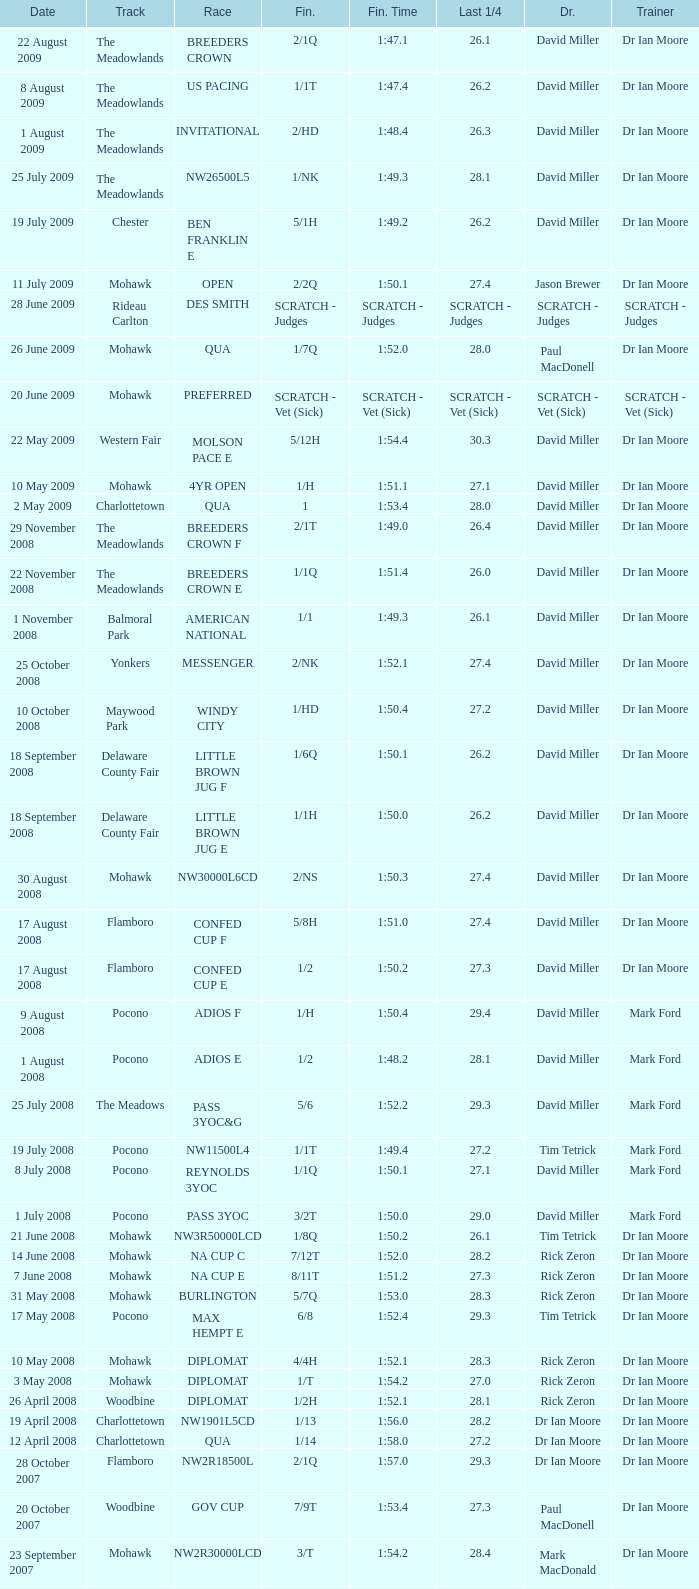What is the last 1/4 for the QUA race with a finishing time of 2:03.1? 29.2. Could you parse the entire table? {'header': ['Date', 'Track', 'Race', 'Fin.', 'Fin. Time', 'Last 1/4', 'Dr.', 'Trainer'], 'rows': [['22 August 2009', 'The Meadowlands', 'BREEDERS CROWN', '2/1Q', '1:47.1', '26.1', 'David Miller', 'Dr Ian Moore'], ['8 August 2009', 'The Meadowlands', 'US PACING', '1/1T', '1:47.4', '26.2', 'David Miller', 'Dr Ian Moore'], ['1 August 2009', 'The Meadowlands', 'INVITATIONAL', '2/HD', '1:48.4', '26.3', 'David Miller', 'Dr Ian Moore'], ['25 July 2009', 'The Meadowlands', 'NW26500L5', '1/NK', '1:49.3', '28.1', 'David Miller', 'Dr Ian Moore'], ['19 July 2009', 'Chester', 'BEN FRANKLIN E', '5/1H', '1:49.2', '26.2', 'David Miller', 'Dr Ian Moore'], ['11 July 2009', 'Mohawk', 'OPEN', '2/2Q', '1:50.1', '27.4', 'Jason Brewer', 'Dr Ian Moore'], ['28 June 2009', 'Rideau Carlton', 'DES SMITH', 'SCRATCH - Judges', 'SCRATCH - Judges', 'SCRATCH - Judges', 'SCRATCH - Judges', 'SCRATCH - Judges'], ['26 June 2009', 'Mohawk', 'QUA', '1/7Q', '1:52.0', '28.0', 'Paul MacDonell', 'Dr Ian Moore'], ['20 June 2009', 'Mohawk', 'PREFERRED', 'SCRATCH - Vet (Sick)', 'SCRATCH - Vet (Sick)', 'SCRATCH - Vet (Sick)', 'SCRATCH - Vet (Sick)', 'SCRATCH - Vet (Sick)'], ['22 May 2009', 'Western Fair', 'MOLSON PACE E', '5/12H', '1:54.4', '30.3', 'David Miller', 'Dr Ian Moore'], ['10 May 2009', 'Mohawk', '4YR OPEN', '1/H', '1:51.1', '27.1', 'David Miller', 'Dr Ian Moore'], ['2 May 2009', 'Charlottetown', 'QUA', '1', '1:53.4', '28.0', 'David Miller', 'Dr Ian Moore'], ['29 November 2008', 'The Meadowlands', 'BREEDERS CROWN F', '2/1T', '1:49.0', '26.4', 'David Miller', 'Dr Ian Moore'], ['22 November 2008', 'The Meadowlands', 'BREEDERS CROWN E', '1/1Q', '1:51.4', '26.0', 'David Miller', 'Dr Ian Moore'], ['1 November 2008', 'Balmoral Park', 'AMERICAN NATIONAL', '1/1', '1:49.3', '26.1', 'David Miller', 'Dr Ian Moore'], ['25 October 2008', 'Yonkers', 'MESSENGER', '2/NK', '1:52.1', '27.4', 'David Miller', 'Dr Ian Moore'], ['10 October 2008', 'Maywood Park', 'WINDY CITY', '1/HD', '1:50.4', '27.2', 'David Miller', 'Dr Ian Moore'], ['18 September 2008', 'Delaware County Fair', 'LITTLE BROWN JUG F', '1/6Q', '1:50.1', '26.2', 'David Miller', 'Dr Ian Moore'], ['18 September 2008', 'Delaware County Fair', 'LITTLE BROWN JUG E', '1/1H', '1:50.0', '26.2', 'David Miller', 'Dr Ian Moore'], ['30 August 2008', 'Mohawk', 'NW30000L6CD', '2/NS', '1:50.3', '27.4', 'David Miller', 'Dr Ian Moore'], ['17 August 2008', 'Flamboro', 'CONFED CUP F', '5/8H', '1:51.0', '27.4', 'David Miller', 'Dr Ian Moore'], ['17 August 2008', 'Flamboro', 'CONFED CUP E', '1/2', '1:50.2', '27.3', 'David Miller', 'Dr Ian Moore'], ['9 August 2008', 'Pocono', 'ADIOS F', '1/H', '1:50.4', '29.4', 'David Miller', 'Mark Ford'], ['1 August 2008', 'Pocono', 'ADIOS E', '1/2', '1:48.2', '28.1', 'David Miller', 'Mark Ford'], ['25 July 2008', 'The Meadows', 'PASS 3YOC&G', '5/6', '1:52.2', '29.3', 'David Miller', 'Mark Ford'], ['19 July 2008', 'Pocono', 'NW11500L4', '1/1T', '1:49.4', '27.2', 'Tim Tetrick', 'Mark Ford'], ['8 July 2008', 'Pocono', 'REYNOLDS 3YOC', '1/1Q', '1:50.1', '27.1', 'David Miller', 'Mark Ford'], ['1 July 2008', 'Pocono', 'PASS 3YOC', '3/2T', '1:50.0', '29.0', 'David Miller', 'Mark Ford'], ['21 June 2008', 'Mohawk', 'NW3R50000LCD', '1/8Q', '1:50.2', '26.1', 'Tim Tetrick', 'Dr Ian Moore'], ['14 June 2008', 'Mohawk', 'NA CUP C', '7/12T', '1:52.0', '28.2', 'Rick Zeron', 'Dr Ian Moore'], ['7 June 2008', 'Mohawk', 'NA CUP E', '8/11T', '1:51.2', '27.3', 'Rick Zeron', 'Dr Ian Moore'], ['31 May 2008', 'Mohawk', 'BURLINGTON', '5/7Q', '1:53.0', '28.3', 'Rick Zeron', 'Dr Ian Moore'], ['17 May 2008', 'Pocono', 'MAX HEMPT E', '6/8', '1:52.4', '29.3', 'Tim Tetrick', 'Dr Ian Moore'], ['10 May 2008', 'Mohawk', 'DIPLOMAT', '4/4H', '1:52.1', '28.3', 'Rick Zeron', 'Dr Ian Moore'], ['3 May 2008', 'Mohawk', 'DIPLOMAT', '1/T', '1:54.2', '27.0', 'Rick Zeron', 'Dr Ian Moore'], ['26 April 2008', 'Woodbine', 'DIPLOMAT', '1/2H', '1:52.1', '28.1', 'Rick Zeron', 'Dr Ian Moore'], ['19 April 2008', 'Charlottetown', 'NW1901L5CD', '1/13', '1:56.0', '28.2', 'Dr Ian Moore', 'Dr Ian Moore'], ['12 April 2008', 'Charlottetown', 'QUA', '1/14', '1:58.0', '27.2', 'Dr Ian Moore', 'Dr Ian Moore'], ['28 October 2007', 'Flamboro', 'NW2R18500L', '2/1Q', '1:57.0', '29.3', 'Dr Ian Moore', 'Dr Ian Moore'], ['20 October 2007', 'Woodbine', 'GOV CUP', '7/9T', '1:53.4', '27.3', 'Paul MacDonell', 'Dr Ian Moore'], ['23 September 2007', 'Mohawk', 'NW2R30000LCD', '3/T', '1:54.2', '28.4', 'Mark MacDonald', 'Dr Ian Moore'], ['15 September 2007', 'Mohawk', 'NASAGAWEYA', '8/12T', '1:55.2', '30.3', 'Mark MacDonald', 'Dr Ian Moore'], ['1 September 2007', 'Mohawk', 'METRO F', '6/9T', '1:51.3', '28.2', 'Mark MacDonald', 'Dr Ian Moore'], ['25 August 2007', 'Mohawk', 'METRO E', '3/4', '1:53.0', '28.1', 'Mark MacDonald', 'Dr Ian Moore'], ['19 August 2007', 'Mohawk', 'NW2R22000LCD', '3/1', '1:53.1', '27.2', 'Paul MacDonell', 'Dr Ian Moore'], ['6 August 2007', 'Mohawk', 'DREAM MAKER', '4/2Q', '1:54.1', '28.1', 'Paul MacDonell', 'Dr Ian Moore'], ['30 July 2007', 'Mohawk', 'DREAM MAKER', '2/1T', '1:53.4', '30.0', 'Dr Ian Moore', 'Dr Ian Moore'], ['23 July 2007', 'Mohawk', 'DREAM MAKER', '2/Q', '1:54.0', '27.4', 'Paul MacDonell', 'Dr Ian Moore'], ['15 July 2007', 'Mohawk', '2YR-C-COND', '1/H', '1:57.2', '27.3', 'Dr Ian Moore', 'Dr Ian Moore'], ['30 June 2007', 'Charlottetown', 'NW2RLFTCD', '1/4H', '1:58.0', '28.1', 'Dr Ian Moore', 'Dr Ian Moore'], ['21 June 2007', 'Charlottetown', 'NW1RLFT', '1/4H', '2:02.3', '29.4', 'Dr Ian Moore', 'Dr Ian Moore'], ['14 June 2007', 'Charlottetown', 'QUA', '1/5H', '2:03.1', '29.2', 'Dr Ian Moore', 'Dr Ian Moore']]} 